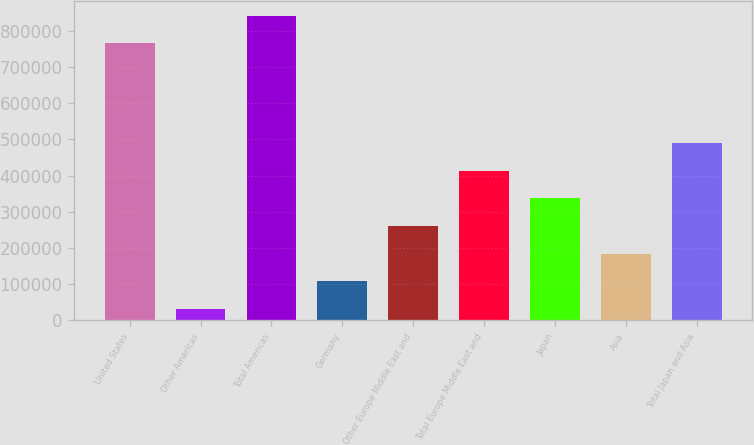Convert chart to OTSL. <chart><loc_0><loc_0><loc_500><loc_500><bar_chart><fcel>United States<fcel>Other Americas<fcel>Total Americas<fcel>Germany<fcel>Other Europe Middle East and<fcel>Total Europe Middle East and<fcel>Japan<fcel>Asia<fcel>Total Japan and Asia<nl><fcel>765120<fcel>31255<fcel>841632<fcel>107767<fcel>260791<fcel>413815<fcel>337303<fcel>184279<fcel>490327<nl></chart> 